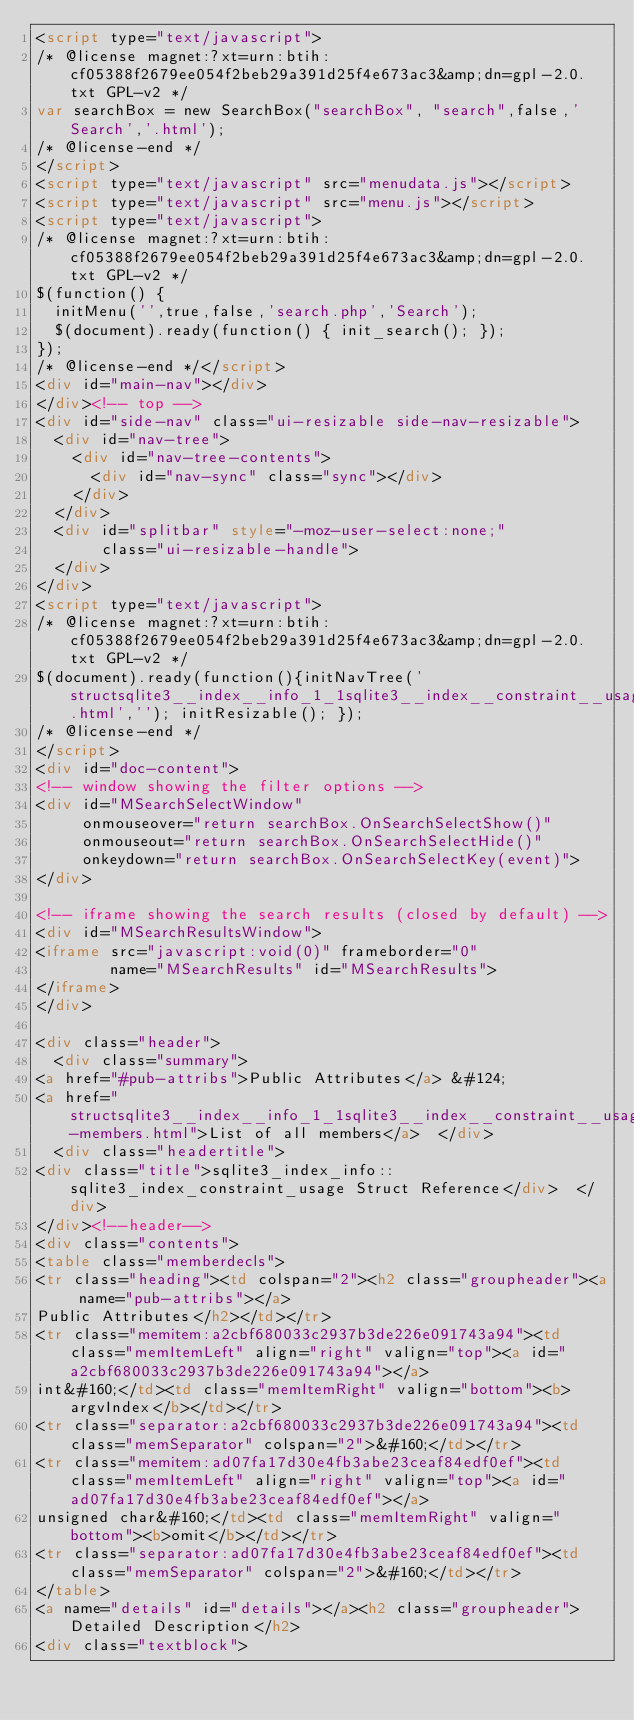Convert code to text. <code><loc_0><loc_0><loc_500><loc_500><_HTML_><script type="text/javascript">
/* @license magnet:?xt=urn:btih:cf05388f2679ee054f2beb29a391d25f4e673ac3&amp;dn=gpl-2.0.txt GPL-v2 */
var searchBox = new SearchBox("searchBox", "search",false,'Search','.html');
/* @license-end */
</script>
<script type="text/javascript" src="menudata.js"></script>
<script type="text/javascript" src="menu.js"></script>
<script type="text/javascript">
/* @license magnet:?xt=urn:btih:cf05388f2679ee054f2beb29a391d25f4e673ac3&amp;dn=gpl-2.0.txt GPL-v2 */
$(function() {
  initMenu('',true,false,'search.php','Search');
  $(document).ready(function() { init_search(); });
});
/* @license-end */</script>
<div id="main-nav"></div>
</div><!-- top -->
<div id="side-nav" class="ui-resizable side-nav-resizable">
  <div id="nav-tree">
    <div id="nav-tree-contents">
      <div id="nav-sync" class="sync"></div>
    </div>
  </div>
  <div id="splitbar" style="-moz-user-select:none;" 
       class="ui-resizable-handle">
  </div>
</div>
<script type="text/javascript">
/* @license magnet:?xt=urn:btih:cf05388f2679ee054f2beb29a391d25f4e673ac3&amp;dn=gpl-2.0.txt GPL-v2 */
$(document).ready(function(){initNavTree('structsqlite3__index__info_1_1sqlite3__index__constraint__usage.html',''); initResizable(); });
/* @license-end */
</script>
<div id="doc-content">
<!-- window showing the filter options -->
<div id="MSearchSelectWindow"
     onmouseover="return searchBox.OnSearchSelectShow()"
     onmouseout="return searchBox.OnSearchSelectHide()"
     onkeydown="return searchBox.OnSearchSelectKey(event)">
</div>

<!-- iframe showing the search results (closed by default) -->
<div id="MSearchResultsWindow">
<iframe src="javascript:void(0)" frameborder="0" 
        name="MSearchResults" id="MSearchResults">
</iframe>
</div>

<div class="header">
  <div class="summary">
<a href="#pub-attribs">Public Attributes</a> &#124;
<a href="structsqlite3__index__info_1_1sqlite3__index__constraint__usage-members.html">List of all members</a>  </div>
  <div class="headertitle">
<div class="title">sqlite3_index_info::sqlite3_index_constraint_usage Struct Reference</div>  </div>
</div><!--header-->
<div class="contents">
<table class="memberdecls">
<tr class="heading"><td colspan="2"><h2 class="groupheader"><a name="pub-attribs"></a>
Public Attributes</h2></td></tr>
<tr class="memitem:a2cbf680033c2937b3de226e091743a94"><td class="memItemLeft" align="right" valign="top"><a id="a2cbf680033c2937b3de226e091743a94"></a>
int&#160;</td><td class="memItemRight" valign="bottom"><b>argvIndex</b></td></tr>
<tr class="separator:a2cbf680033c2937b3de226e091743a94"><td class="memSeparator" colspan="2">&#160;</td></tr>
<tr class="memitem:ad07fa17d30e4fb3abe23ceaf84edf0ef"><td class="memItemLeft" align="right" valign="top"><a id="ad07fa17d30e4fb3abe23ceaf84edf0ef"></a>
unsigned char&#160;</td><td class="memItemRight" valign="bottom"><b>omit</b></td></tr>
<tr class="separator:ad07fa17d30e4fb3abe23ceaf84edf0ef"><td class="memSeparator" colspan="2">&#160;</td></tr>
</table>
<a name="details" id="details"></a><h2 class="groupheader">Detailed Description</h2>
<div class="textblock"></code> 